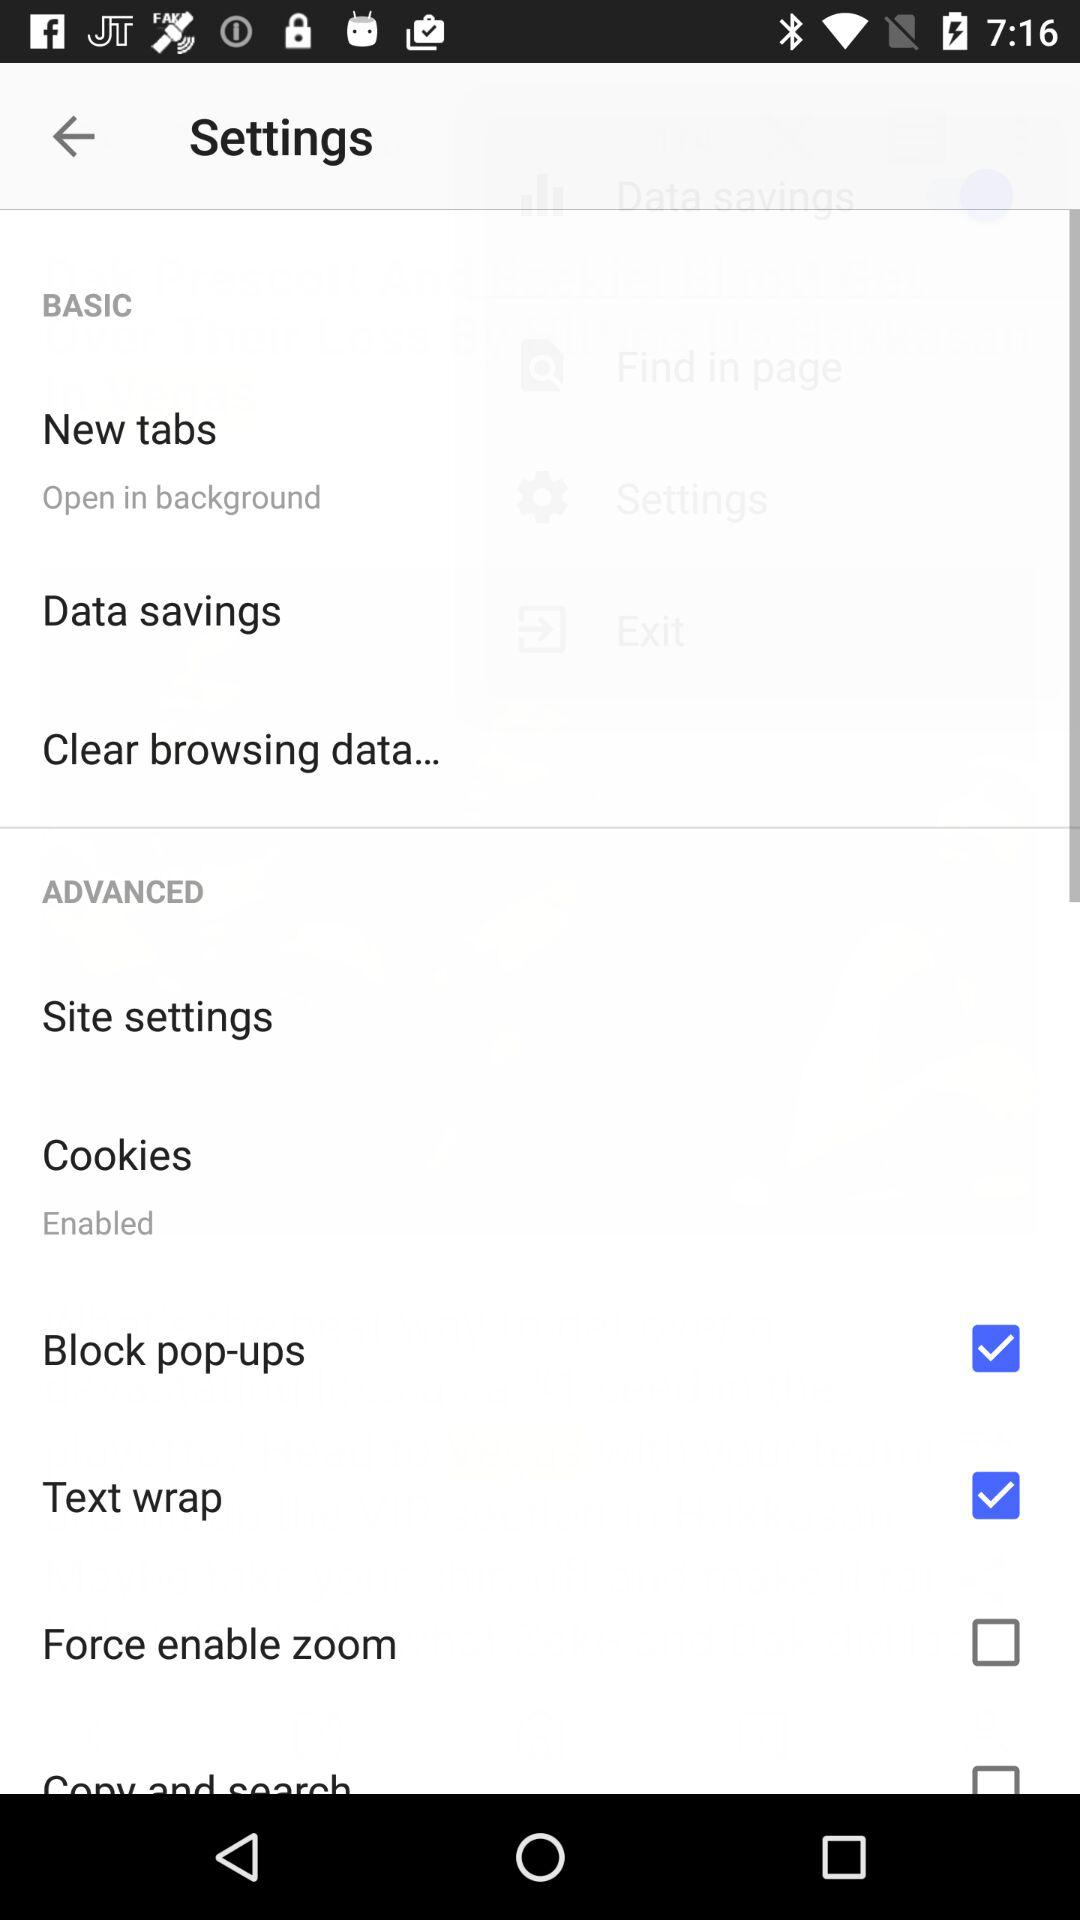Is "Site settings" checked or unchecked?
When the provided information is insufficient, respond with <no answer>. <no answer> 